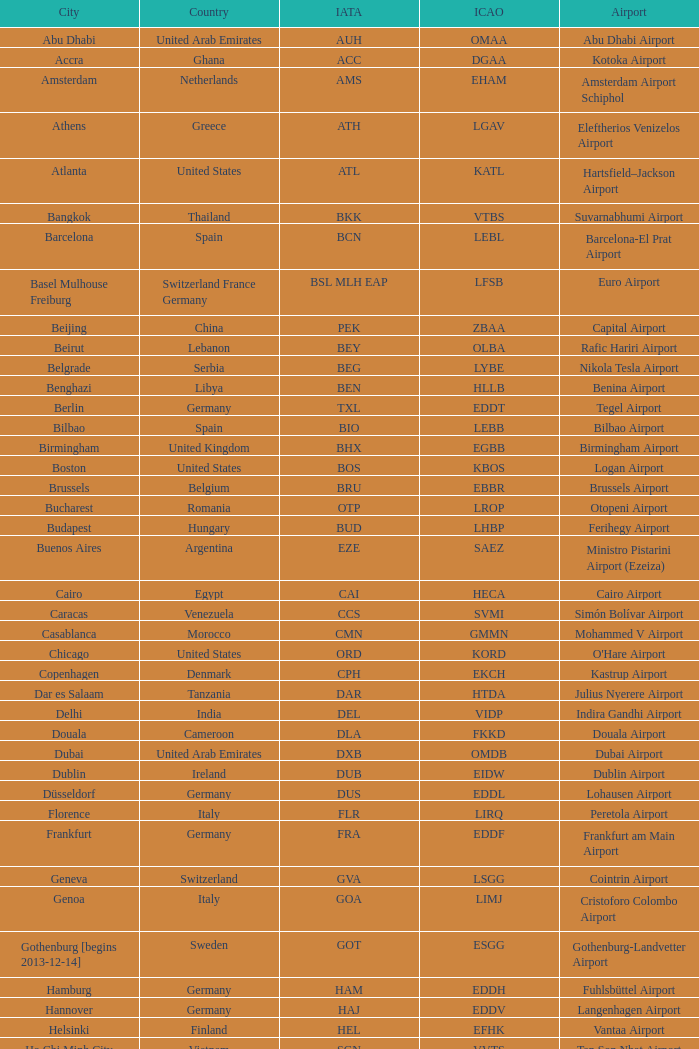What is the icao identifier for lohausen airport? EDDL. Could you parse the entire table? {'header': ['City', 'Country', 'IATA', 'ICAO', 'Airport'], 'rows': [['Abu Dhabi', 'United Arab Emirates', 'AUH', 'OMAA', 'Abu Dhabi Airport'], ['Accra', 'Ghana', 'ACC', 'DGAA', 'Kotoka Airport'], ['Amsterdam', 'Netherlands', 'AMS', 'EHAM', 'Amsterdam Airport Schiphol'], ['Athens', 'Greece', 'ATH', 'LGAV', 'Eleftherios Venizelos Airport'], ['Atlanta', 'United States', 'ATL', 'KATL', 'Hartsfield–Jackson Airport'], ['Bangkok', 'Thailand', 'BKK', 'VTBS', 'Suvarnabhumi Airport'], ['Barcelona', 'Spain', 'BCN', 'LEBL', 'Barcelona-El Prat Airport'], ['Basel Mulhouse Freiburg', 'Switzerland France Germany', 'BSL MLH EAP', 'LFSB', 'Euro Airport'], ['Beijing', 'China', 'PEK', 'ZBAA', 'Capital Airport'], ['Beirut', 'Lebanon', 'BEY', 'OLBA', 'Rafic Hariri Airport'], ['Belgrade', 'Serbia', 'BEG', 'LYBE', 'Nikola Tesla Airport'], ['Benghazi', 'Libya', 'BEN', 'HLLB', 'Benina Airport'], ['Berlin', 'Germany', 'TXL', 'EDDT', 'Tegel Airport'], ['Bilbao', 'Spain', 'BIO', 'LEBB', 'Bilbao Airport'], ['Birmingham', 'United Kingdom', 'BHX', 'EGBB', 'Birmingham Airport'], ['Boston', 'United States', 'BOS', 'KBOS', 'Logan Airport'], ['Brussels', 'Belgium', 'BRU', 'EBBR', 'Brussels Airport'], ['Bucharest', 'Romania', 'OTP', 'LROP', 'Otopeni Airport'], ['Budapest', 'Hungary', 'BUD', 'LHBP', 'Ferihegy Airport'], ['Buenos Aires', 'Argentina', 'EZE', 'SAEZ', 'Ministro Pistarini Airport (Ezeiza)'], ['Cairo', 'Egypt', 'CAI', 'HECA', 'Cairo Airport'], ['Caracas', 'Venezuela', 'CCS', 'SVMI', 'Simón Bolívar Airport'], ['Casablanca', 'Morocco', 'CMN', 'GMMN', 'Mohammed V Airport'], ['Chicago', 'United States', 'ORD', 'KORD', "O'Hare Airport"], ['Copenhagen', 'Denmark', 'CPH', 'EKCH', 'Kastrup Airport'], ['Dar es Salaam', 'Tanzania', 'DAR', 'HTDA', 'Julius Nyerere Airport'], ['Delhi', 'India', 'DEL', 'VIDP', 'Indira Gandhi Airport'], ['Douala', 'Cameroon', 'DLA', 'FKKD', 'Douala Airport'], ['Dubai', 'United Arab Emirates', 'DXB', 'OMDB', 'Dubai Airport'], ['Dublin', 'Ireland', 'DUB', 'EIDW', 'Dublin Airport'], ['Düsseldorf', 'Germany', 'DUS', 'EDDL', 'Lohausen Airport'], ['Florence', 'Italy', 'FLR', 'LIRQ', 'Peretola Airport'], ['Frankfurt', 'Germany', 'FRA', 'EDDF', 'Frankfurt am Main Airport'], ['Geneva', 'Switzerland', 'GVA', 'LSGG', 'Cointrin Airport'], ['Genoa', 'Italy', 'GOA', 'LIMJ', 'Cristoforo Colombo Airport'], ['Gothenburg [begins 2013-12-14]', 'Sweden', 'GOT', 'ESGG', 'Gothenburg-Landvetter Airport'], ['Hamburg', 'Germany', 'HAM', 'EDDH', 'Fuhlsbüttel Airport'], ['Hannover', 'Germany', 'HAJ', 'EDDV', 'Langenhagen Airport'], ['Helsinki', 'Finland', 'HEL', 'EFHK', 'Vantaa Airport'], ['Ho Chi Minh City', 'Vietnam', 'SGN', 'VVTS', 'Tan Son Nhat Airport'], ['Hong Kong', 'Hong Kong', 'HKG', 'VHHH', 'Chek Lap Kok Airport'], ['Istanbul', 'Turkey', 'IST', 'LTBA', 'Atatürk Airport'], ['Jakarta', 'Indonesia', 'CGK', 'WIII', 'Soekarno–Hatta Airport'], ['Jeddah', 'Saudi Arabia', 'JED', 'OEJN', 'King Abdulaziz Airport'], ['Johannesburg', 'South Africa', 'JNB', 'FAJS', 'OR Tambo Airport'], ['Karachi', 'Pakistan', 'KHI', 'OPKC', 'Jinnah Airport'], ['Kiev', 'Ukraine', 'KBP', 'UKBB', 'Boryspil International Airport'], ['Lagos', 'Nigeria', 'LOS', 'DNMM', 'Murtala Muhammed Airport'], ['Libreville', 'Gabon', 'LBV', 'FOOL', "Leon M'ba Airport"], ['Lisbon', 'Portugal', 'LIS', 'LPPT', 'Portela Airport'], ['London', 'United Kingdom', 'LCY', 'EGLC', 'City Airport'], ['London [begins 2013-12-14]', 'United Kingdom', 'LGW', 'EGKK', 'Gatwick Airport'], ['London', 'United Kingdom', 'LHR', 'EGLL', 'Heathrow Airport'], ['Los Angeles', 'United States', 'LAX', 'KLAX', 'Los Angeles International Airport'], ['Lugano', 'Switzerland', 'LUG', 'LSZA', 'Agno Airport'], ['Luxembourg City', 'Luxembourg', 'LUX', 'ELLX', 'Findel Airport'], ['Lyon', 'France', 'LYS', 'LFLL', 'Saint-Exupéry Airport'], ['Madrid', 'Spain', 'MAD', 'LEMD', 'Madrid-Barajas Airport'], ['Malabo', 'Equatorial Guinea', 'SSG', 'FGSL', 'Saint Isabel Airport'], ['Malaga', 'Spain', 'AGP', 'LEMG', 'Málaga-Costa del Sol Airport'], ['Manchester', 'United Kingdom', 'MAN', 'EGCC', 'Ringway Airport'], ['Manila', 'Philippines', 'MNL', 'RPLL', 'Ninoy Aquino Airport'], ['Marrakech [begins 2013-11-01]', 'Morocco', 'RAK', 'GMMX', 'Menara Airport'], ['Miami', 'United States', 'MIA', 'KMIA', 'Miami Airport'], ['Milan', 'Italy', 'MXP', 'LIMC', 'Malpensa Airport'], ['Minneapolis', 'United States', 'MSP', 'KMSP', 'Minneapolis Airport'], ['Montreal', 'Canada', 'YUL', 'CYUL', 'Pierre Elliott Trudeau Airport'], ['Moscow', 'Russia', 'DME', 'UUDD', 'Domodedovo Airport'], ['Mumbai', 'India', 'BOM', 'VABB', 'Chhatrapati Shivaji Airport'], ['Munich', 'Germany', 'MUC', 'EDDM', 'Franz Josef Strauss Airport'], ['Muscat', 'Oman', 'MCT', 'OOMS', 'Seeb Airport'], ['Nairobi', 'Kenya', 'NBO', 'HKJK', 'Jomo Kenyatta Airport'], ['Newark', 'United States', 'EWR', 'KEWR', 'Liberty Airport'], ['New York City', 'United States', 'JFK', 'KJFK', 'John F Kennedy Airport'], ['Nice', 'France', 'NCE', 'LFMN', "Côte d'Azur Airport"], ['Nuremberg', 'Germany', 'NUE', 'EDDN', 'Nuremberg Airport'], ['Oslo', 'Norway', 'OSL', 'ENGM', 'Gardermoen Airport'], ['Palma de Mallorca', 'Spain', 'PMI', 'LFPA', 'Palma de Mallorca Airport'], ['Paris', 'France', 'CDG', 'LFPG', 'Charles de Gaulle Airport'], ['Porto', 'Portugal', 'OPO', 'LPPR', 'Francisco de Sa Carneiro Airport'], ['Prague', 'Czech Republic', 'PRG', 'LKPR', 'Ruzyně Airport'], ['Riga', 'Latvia', 'RIX', 'EVRA', 'Riga Airport'], ['Rio de Janeiro [resumes 2014-7-14]', 'Brazil', 'GIG', 'SBGL', 'Galeão Airport'], ['Riyadh', 'Saudi Arabia', 'RUH', 'OERK', 'King Khalid Airport'], ['Rome', 'Italy', 'FCO', 'LIRF', 'Leonardo da Vinci Airport'], ['Saint Petersburg', 'Russia', 'LED', 'ULLI', 'Pulkovo Airport'], ['San Francisco', 'United States', 'SFO', 'KSFO', 'San Francisco Airport'], ['Santiago', 'Chile', 'SCL', 'SCEL', 'Comodoro Arturo Benitez Airport'], ['São Paulo', 'Brazil', 'GRU', 'SBGR', 'Guarulhos Airport'], ['Sarajevo', 'Bosnia and Herzegovina', 'SJJ', 'LQSA', 'Butmir Airport'], ['Seattle', 'United States', 'SEA', 'KSEA', 'Sea-Tac Airport'], ['Shanghai', 'China', 'PVG', 'ZSPD', 'Pudong Airport'], ['Singapore', 'Singapore', 'SIN', 'WSSS', 'Changi Airport'], ['Skopje', 'Republic of Macedonia', 'SKP', 'LWSK', 'Alexander the Great Airport'], ['Sofia', 'Bulgaria', 'SOF', 'LBSF', 'Vrazhdebna Airport'], ['Stockholm', 'Sweden', 'ARN', 'ESSA', 'Arlanda Airport'], ['Stuttgart', 'Germany', 'STR', 'EDDS', 'Echterdingen Airport'], ['Taipei', 'Taiwan', 'TPE', 'RCTP', 'Taoyuan Airport'], ['Tehran', 'Iran', 'IKA', 'OIIE', 'Imam Khomeini Airport'], ['Tel Aviv', 'Israel', 'TLV', 'LLBG', 'Ben Gurion Airport'], ['Thessaloniki', 'Greece', 'SKG', 'LGTS', 'Macedonia Airport'], ['Tirana', 'Albania', 'TIA', 'LATI', 'Nënë Tereza Airport'], ['Tokyo', 'Japan', 'NRT', 'RJAA', 'Narita Airport'], ['Toronto', 'Canada', 'YYZ', 'CYYZ', 'Pearson Airport'], ['Tripoli', 'Libya', 'TIP', 'HLLT', 'Tripoli Airport'], ['Tunis', 'Tunisia', 'TUN', 'DTTA', 'Carthage Airport'], ['Turin', 'Italy', 'TRN', 'LIMF', 'Sandro Pertini Airport'], ['Valencia', 'Spain', 'VLC', 'LEVC', 'Valencia Airport'], ['Venice', 'Italy', 'VCE', 'LIPZ', 'Marco Polo Airport'], ['Vienna', 'Austria', 'VIE', 'LOWW', 'Schwechat Airport'], ['Warsaw', 'Poland', 'WAW', 'EPWA', 'Frederic Chopin Airport'], ['Washington DC', 'United States', 'IAD', 'KIAD', 'Dulles Airport'], ['Yaounde', 'Cameroon', 'NSI', 'FKYS', 'Yaounde Nsimalen Airport'], ['Yerevan', 'Armenia', 'EVN', 'UDYZ', 'Zvartnots Airport'], ['Zurich', 'Switzerland', 'ZRH', 'LSZH', 'Zurich Airport']]} 